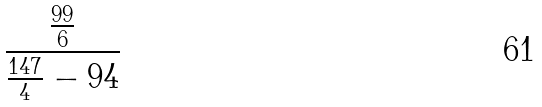<formula> <loc_0><loc_0><loc_500><loc_500>\frac { \frac { 9 9 } { 6 } } { \frac { 1 4 7 } { 4 } - 9 4 }</formula> 